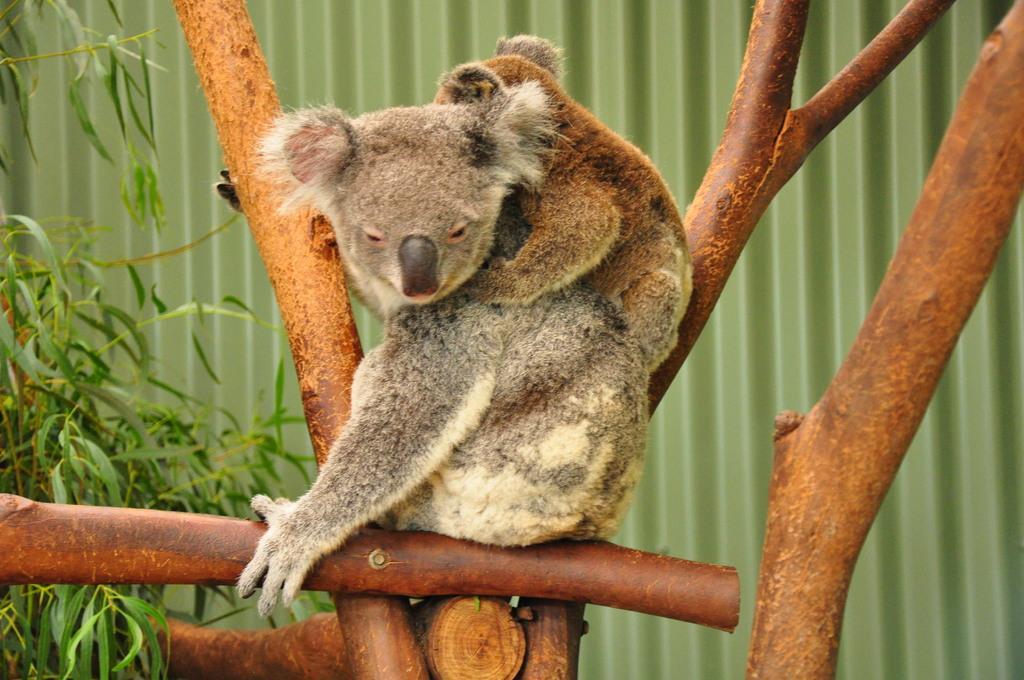How would you summarize this image in a sentence or two? In the background we can see the metal panel. In this picture we can see animals and branches. On the left side of the picture we can see the green leaves. 